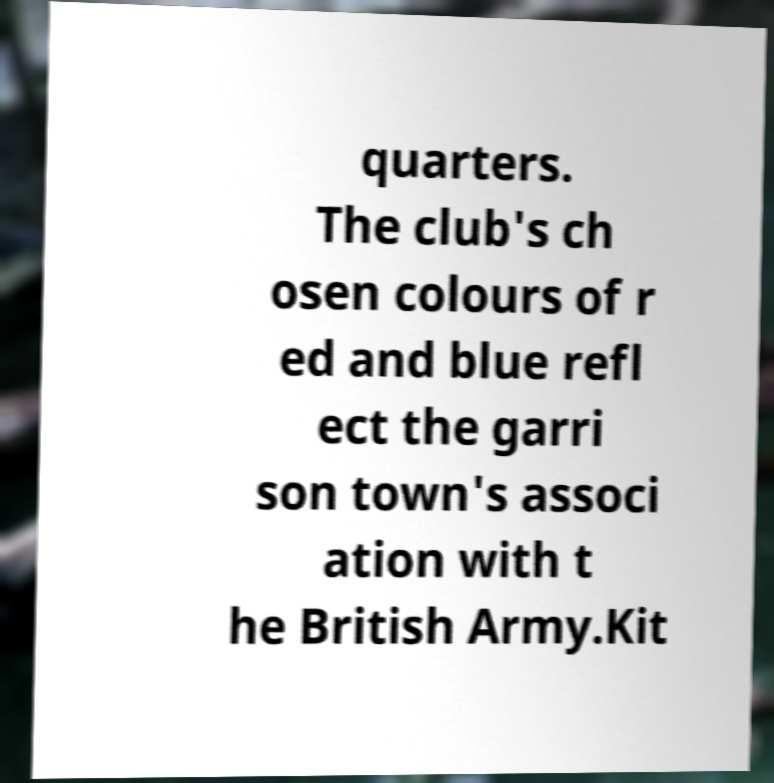For documentation purposes, I need the text within this image transcribed. Could you provide that? quarters. The club's ch osen colours of r ed and blue refl ect the garri son town's associ ation with t he British Army.Kit 